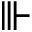Convert formula to latex. <formula><loc_0><loc_0><loc_500><loc_500>\ V v d a s h</formula> 